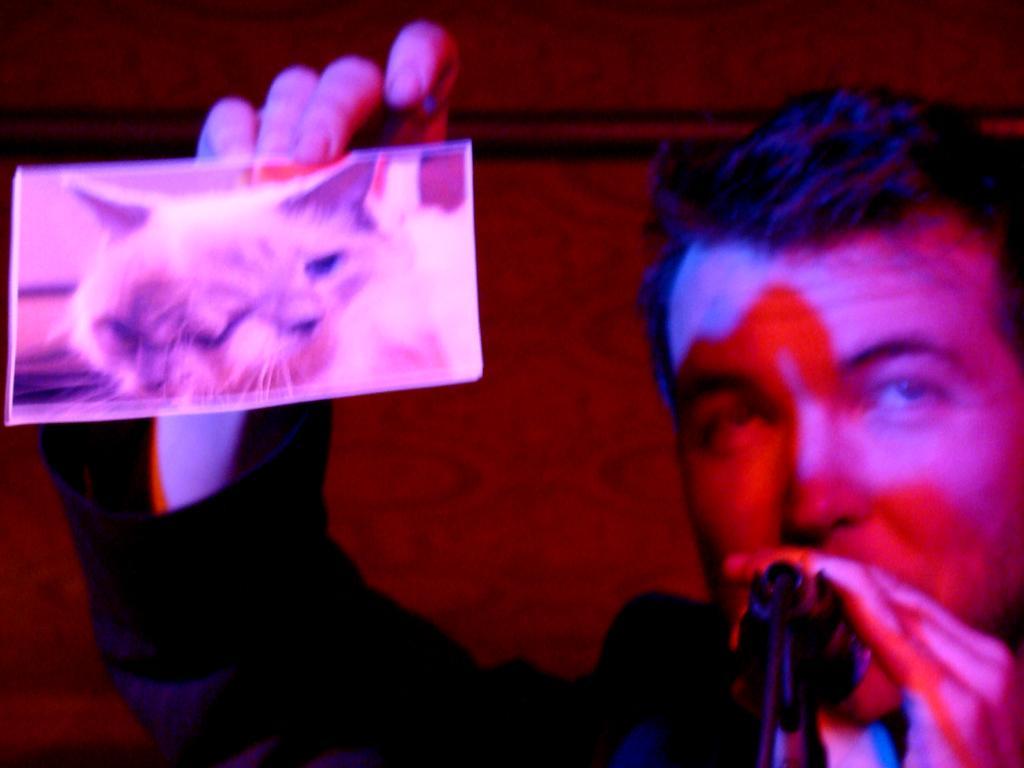Please provide a concise description of this image. In this image there is a person standing, in front of him there is a mic and he is holding a photo of a cat. In the background there is a wall. 